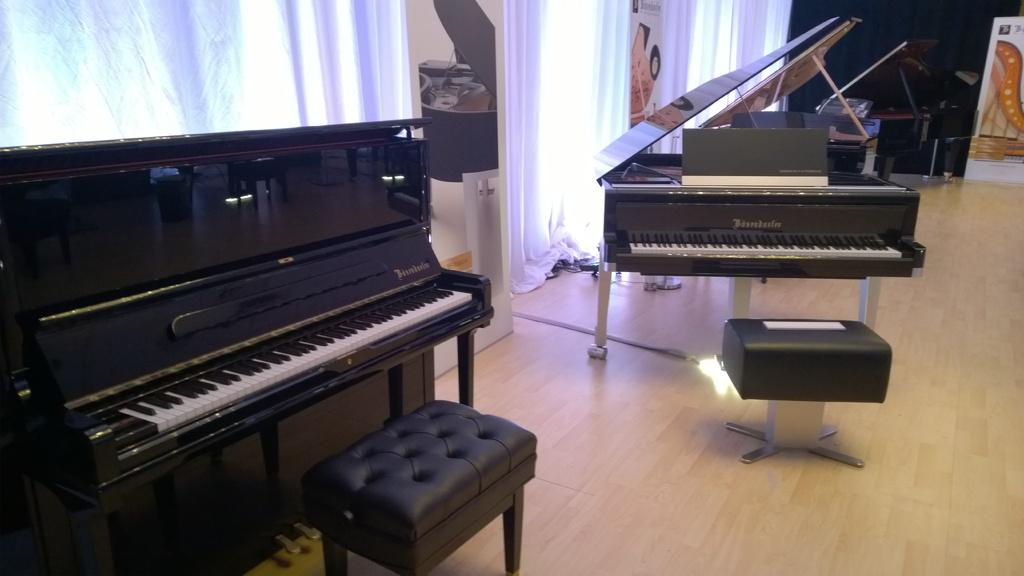What is the main object in the center of the image? There is a piano in the center of the image. What is placed in front of the piano? There is a stool in front of the piano. What other musical instrument can be seen in the image? There is another musical instrument on the left side of the image. What can be seen in the background of the image? There is a curtain, a wall, and a banner in the background of the image. What time of day is it in the image, and is there a kitty playing with a ball of yarn in the lunchroom? The time of day cannot be determined from the image, and there is no lunchroom or kitty playing with a ball of yarn present in the image. 